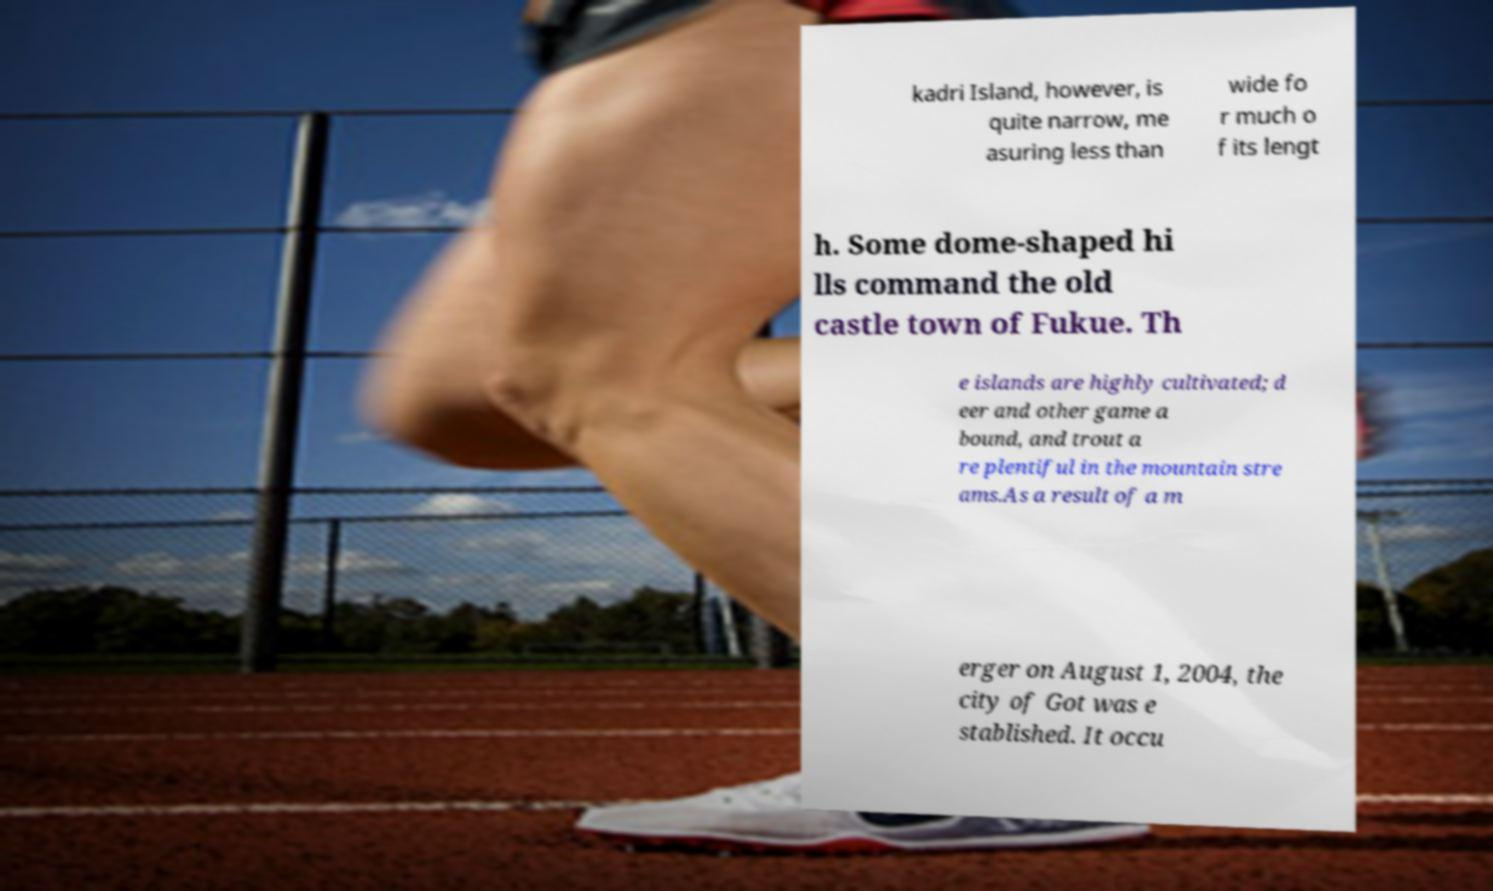Please read and relay the text visible in this image. What does it say? kadri Island, however, is quite narrow, me asuring less than wide fo r much o f its lengt h. Some dome-shaped hi lls command the old castle town of Fukue. Th e islands are highly cultivated; d eer and other game a bound, and trout a re plentiful in the mountain stre ams.As a result of a m erger on August 1, 2004, the city of Got was e stablished. It occu 